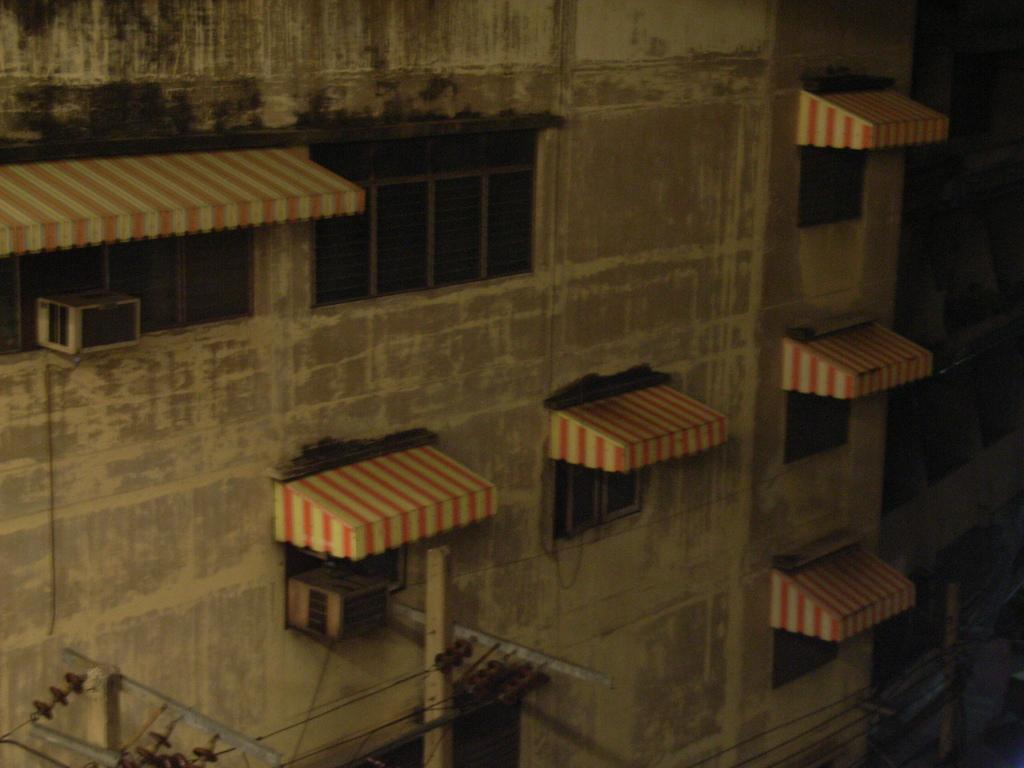What type of structure is visible in the image? There is a building in the image. What features can be seen on the building? The building has windows and shades. What is used for cooling the building? There is an AC in the building. What else can be seen in the image besides the building? There are electric poles with wires in the image. What type of flesh can be seen hanging from the electric poles in the image? There is no flesh present in the image; the electric poles have wires, not flesh. 